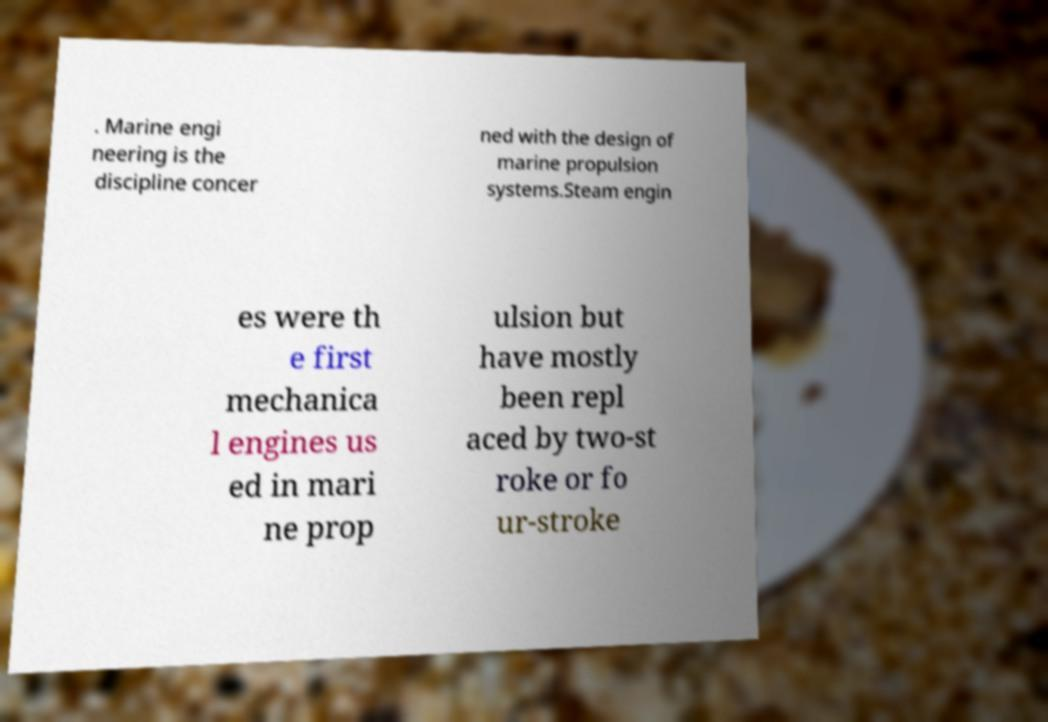Could you extract and type out the text from this image? . Marine engi neering is the discipline concer ned with the design of marine propulsion systems.Steam engin es were th e first mechanica l engines us ed in mari ne prop ulsion but have mostly been repl aced by two-st roke or fo ur-stroke 